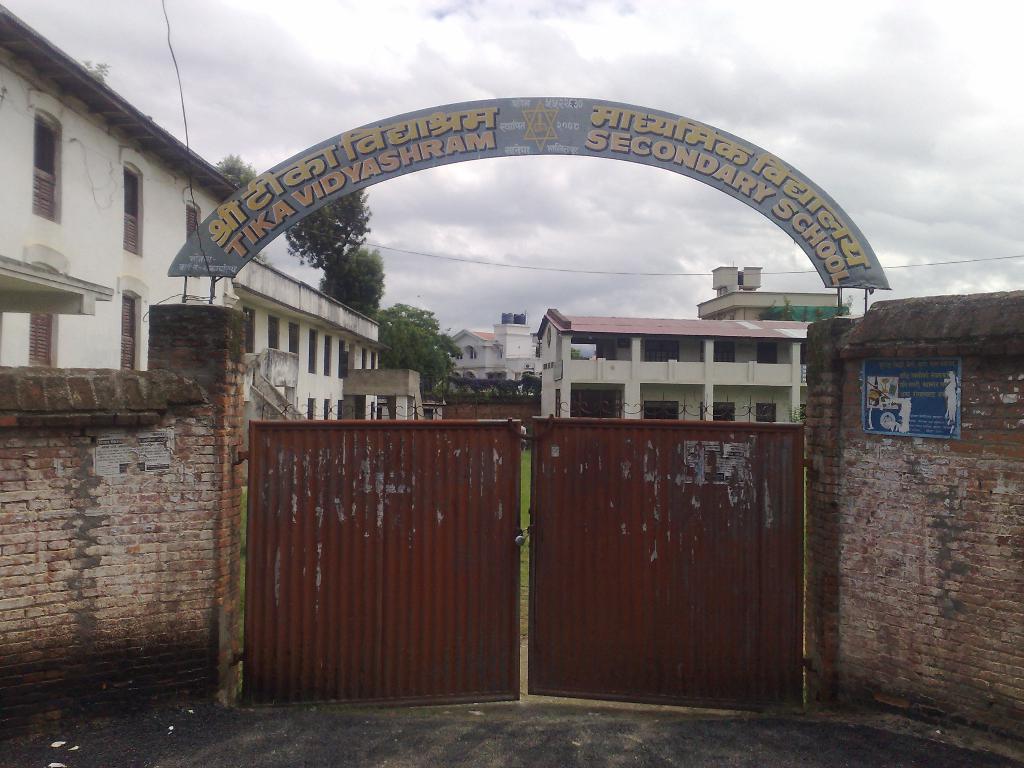Describe this image in one or two sentences. In this image i can see a red colored gate and a arch to the school, To the both sides of the image i can see the fence wall. In the background i can see few buildings, few trees and the sky. 